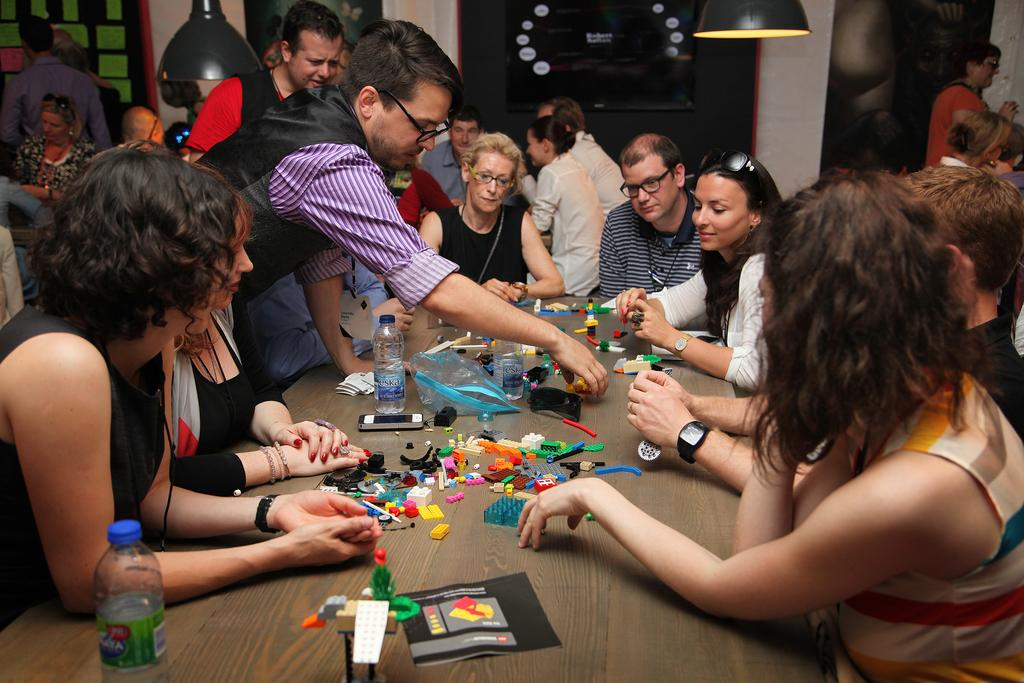Who or what is present in the image? There are people in the image. What can be seen illuminating the scene? There are lights in the image. What piece of furniture is visible in the image? There is a table in the image. What type of containers are on the table? There are bottles on the table. What other items are on the table besides the bottles? There are other unspecified items on the table. What is the name of the glue used to attach the list to the table in the image? There is no glue or list present in the image. 